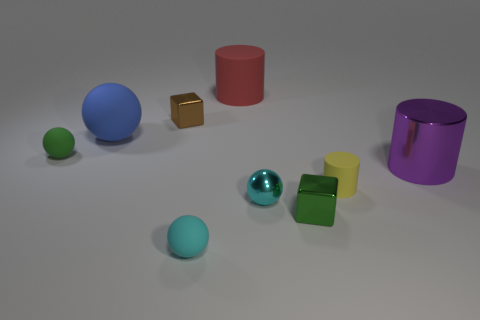Is there a cyan object of the same size as the yellow rubber object?
Ensure brevity in your answer.  Yes. Are there more brown objects that are behind the blue matte ball than tiny green matte balls on the right side of the brown object?
Keep it short and to the point. Yes. Does the small object behind the green rubber thing have the same material as the small green object left of the tiny brown shiny thing?
Offer a terse response. No. What shape is the red thing that is the same size as the purple shiny cylinder?
Your answer should be very brief. Cylinder. Is there another tiny thing of the same shape as the tiny green metallic thing?
Give a very brief answer. Yes. There is a shiny block that is in front of the yellow rubber thing; is its color the same as the small rubber ball behind the tiny yellow object?
Your response must be concise. Yes. Are there any small green shiny things in front of the cyan matte object?
Give a very brief answer. No. What is the object that is both behind the green metallic cube and in front of the small yellow cylinder made of?
Offer a terse response. Metal. Are the tiny green thing that is to the left of the tiny cyan shiny thing and the small yellow cylinder made of the same material?
Your answer should be very brief. Yes. What material is the big red thing?
Provide a succinct answer. Rubber. 